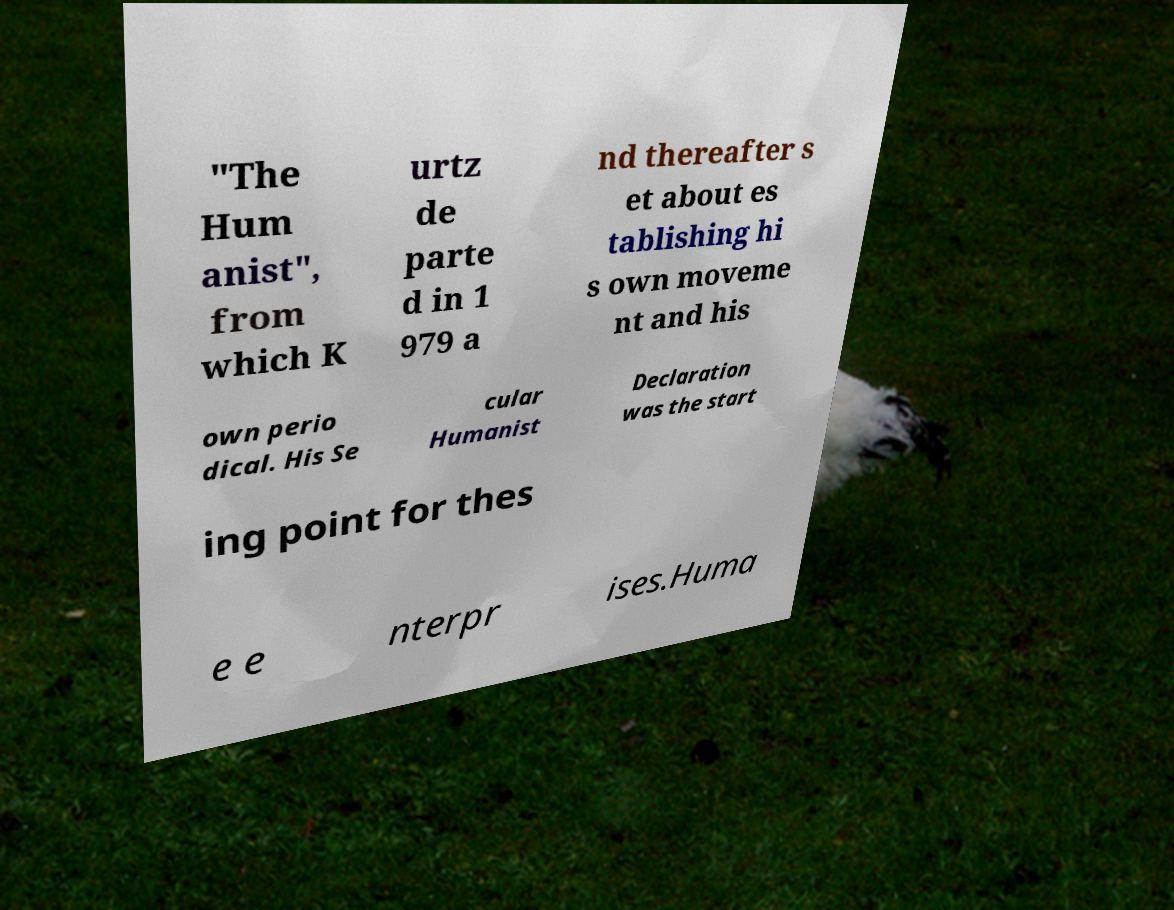Can you read and provide the text displayed in the image?This photo seems to have some interesting text. Can you extract and type it out for me? "The Hum anist", from which K urtz de parte d in 1 979 a nd thereafter s et about es tablishing hi s own moveme nt and his own perio dical. His Se cular Humanist Declaration was the start ing point for thes e e nterpr ises.Huma 